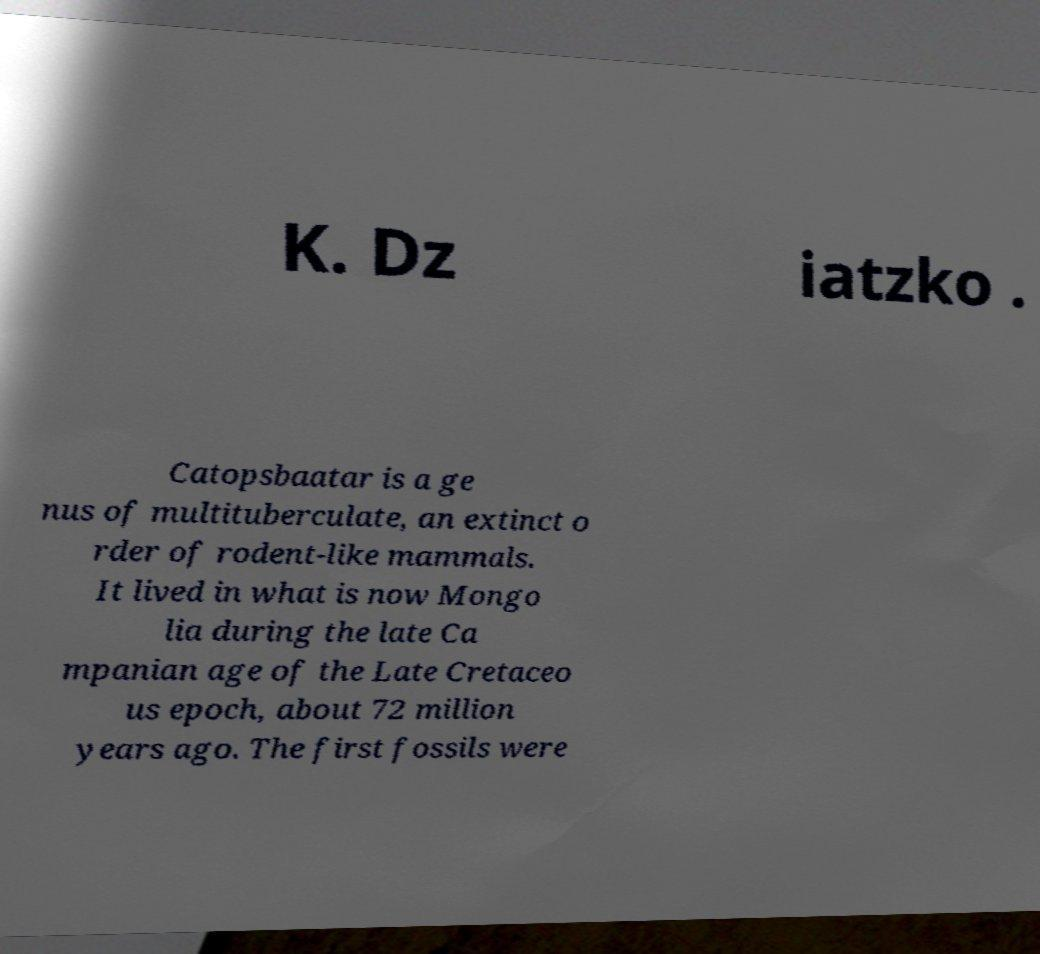I need the written content from this picture converted into text. Can you do that? K. Dz iatzko . Catopsbaatar is a ge nus of multituberculate, an extinct o rder of rodent-like mammals. It lived in what is now Mongo lia during the late Ca mpanian age of the Late Cretaceo us epoch, about 72 million years ago. The first fossils were 